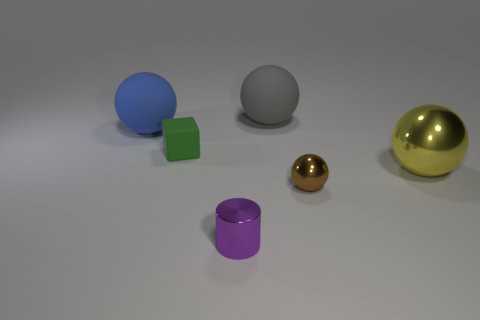How many other things are there of the same color as the tiny cylinder?
Make the answer very short. 0. What number of blue metal spheres are there?
Offer a terse response. 0. Do the rubber thing to the right of the small green cube and the purple shiny thing that is in front of the tiny brown sphere have the same size?
Provide a short and direct response. No. What color is the tiny metallic object that is the same shape as the big metallic object?
Provide a short and direct response. Brown. Do the gray object and the green rubber object have the same shape?
Your response must be concise. No. There is a blue object that is the same shape as the yellow shiny thing; what size is it?
Keep it short and to the point. Large. What number of yellow things are the same material as the tiny purple cylinder?
Ensure brevity in your answer.  1. How many objects are either blue metal things or metal things?
Give a very brief answer. 3. There is a sphere that is in front of the yellow sphere; are there any big spheres in front of it?
Your response must be concise. No. Is the number of tiny purple metallic objects behind the brown metal object greater than the number of green rubber objects that are left of the big shiny sphere?
Offer a very short reply. No. 